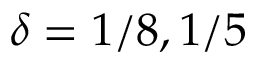Convert formula to latex. <formula><loc_0><loc_0><loc_500><loc_500>\delta = 1 / 8 , 1 / 5</formula> 